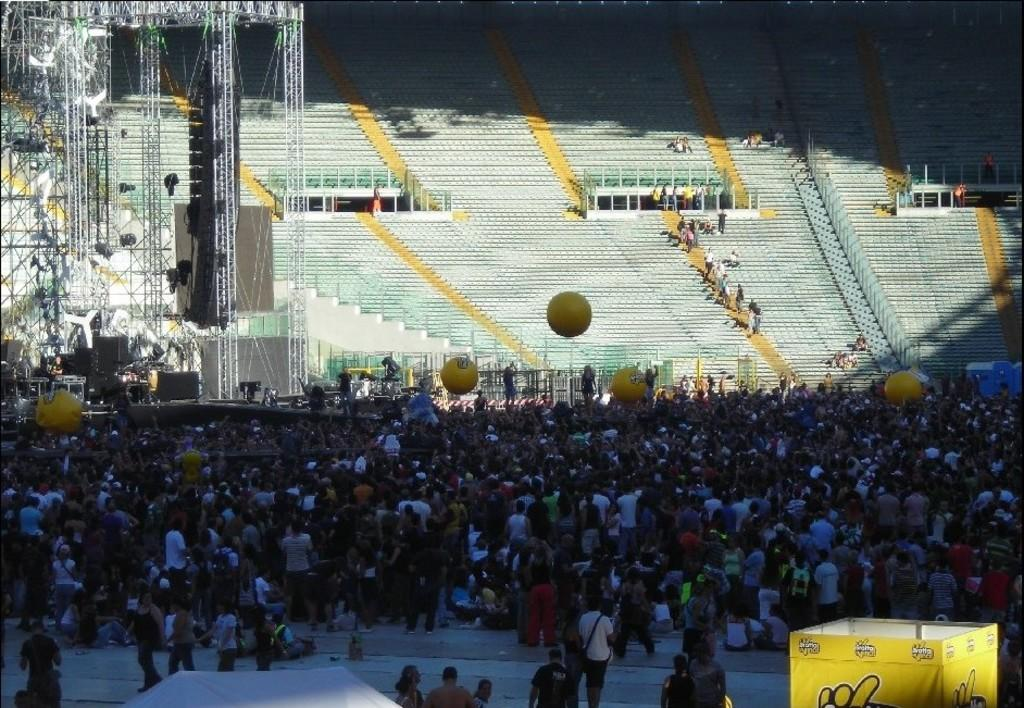What color is the box on the right side of the image? The box on the right side of the image is yellow. How many people can be seen in the image? Many people are present in the image. What can be seen in the background of the image? There is a stadium visible in the background of the image. What is located on the left side of the image? There are wires on the left side of the image. Can you tell me how many pickles are on the wires in the image? There are no pickles present in the image; only wires are visible on the left side. What type of quiver is being used by the people in the image? There is no quiver present in the image; the people are not holding any such objects. 